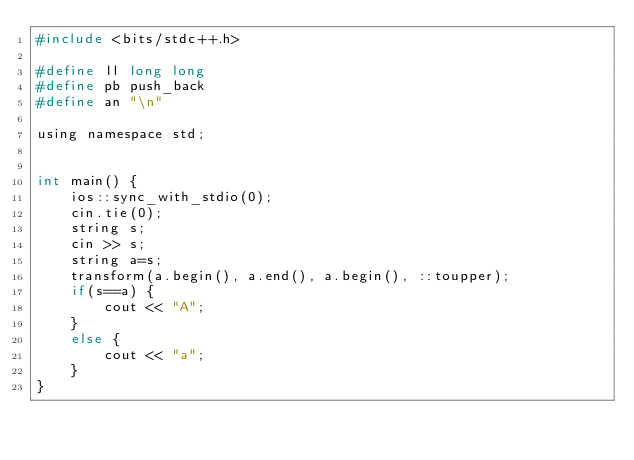<code> <loc_0><loc_0><loc_500><loc_500><_C_>#include <bits/stdc++.h>

#define ll long long
#define pb push_back
#define an "\n"

using namespace std;


int main() {
	ios::sync_with_stdio(0);
	cin.tie(0);
	string s;
	cin >> s;
	string a=s;
	transform(a.begin(), a.end(), a.begin(), ::toupper);
	if(s==a) {
		cout << "A";
	}
	else {
		cout << "a";
	}
}

</code> 